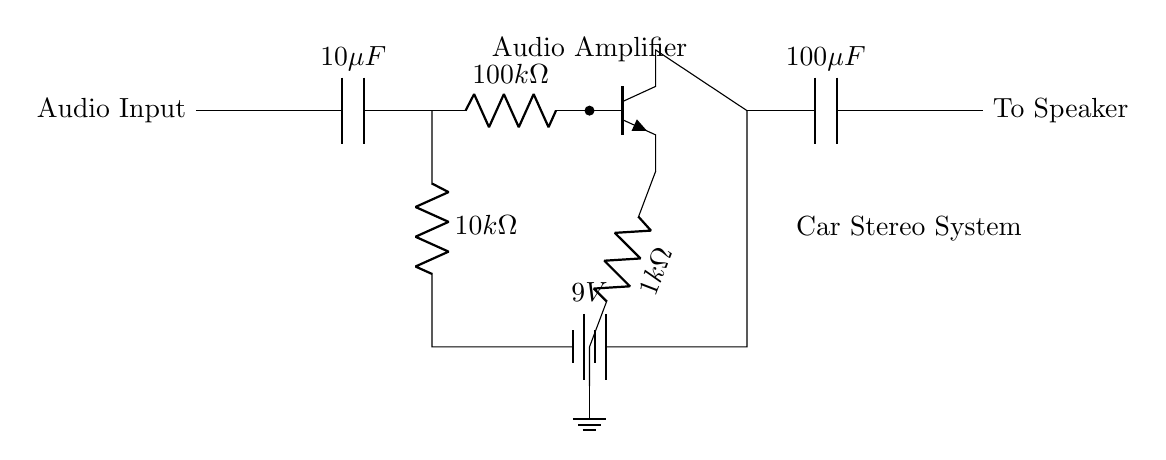What is the input component of the circuit? The input component is a capacitor that holds an audio signal, indicated as a 10 microfarad capacitor connected to the audio input.
Answer: 10 microfarad capacitor What is the value of the battery voltage? The battery voltage is specified in the circuit diagram as 9 volts, indicating the power supply for the amplifier circuit.
Answer: 9 volts What is the resistance value connected to the transistor's emitter? The resistor connected to the emitter of the transistor has a value of 1 kiloohm, which influences the gain of the amplifier.
Answer: 1 kiloohm Describe the output component of the circuit. The output component is a capacitor that couples the amplified audio signal to the speaker, with a value of 100 microfarads.
Answer: 100 microfarads Why is there a grounding in this circuit? Grounding provides a common reference point in the circuit, ensuring that all components have a stable return path for the current, which is crucial for the proper operation of the amplifier.
Answer: Common reference point What is the role of the 100 kiloohm resistor in the circuit? The 100 kiloohm resistor is connected to the base of the transistor and serves to set the base current, influencing the transistor’s operation and the overall gain of the amplifier.
Answer: Set base current What component is used to filter the output signal? The component used to filter the output signal is the capacitor labeled as 100 microfarads, which blocks DC while allowing AC signals to pass to the speaker.
Answer: 100 microfarads capacitor 